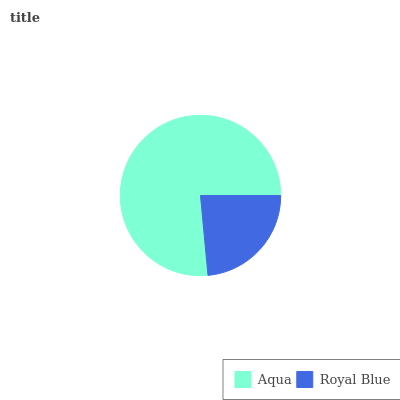Is Royal Blue the minimum?
Answer yes or no. Yes. Is Aqua the maximum?
Answer yes or no. Yes. Is Royal Blue the maximum?
Answer yes or no. No. Is Aqua greater than Royal Blue?
Answer yes or no. Yes. Is Royal Blue less than Aqua?
Answer yes or no. Yes. Is Royal Blue greater than Aqua?
Answer yes or no. No. Is Aqua less than Royal Blue?
Answer yes or no. No. Is Aqua the high median?
Answer yes or no. Yes. Is Royal Blue the low median?
Answer yes or no. Yes. Is Royal Blue the high median?
Answer yes or no. No. Is Aqua the low median?
Answer yes or no. No. 